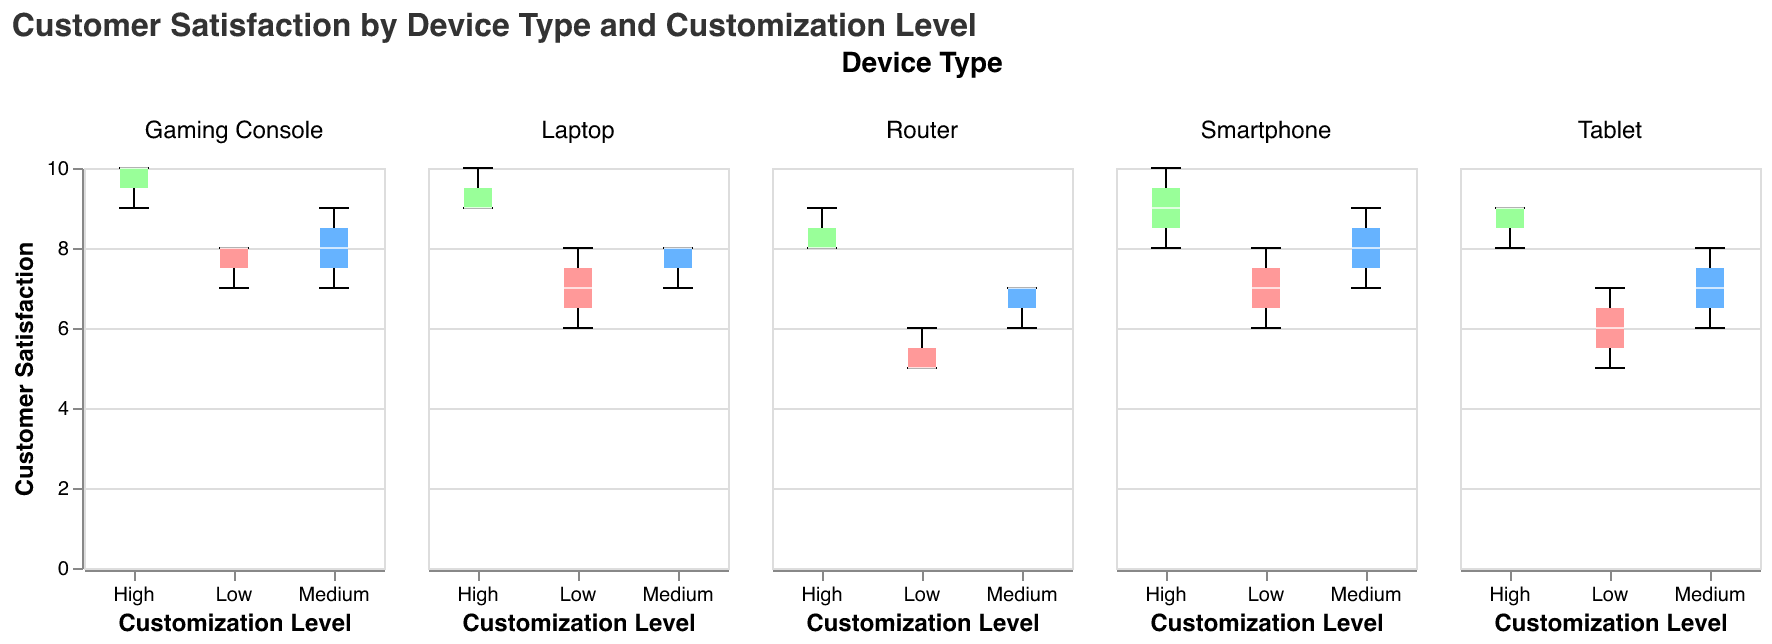What is the title of the figure? The title of the figure is located at the top of the plot and it reads: "Customer Satisfaction by Device Type and Customization Level".
Answer: Customer Satisfaction by Device Type and Customization Level What is the range of the customer satisfaction axis? The y-axis represents customer satisfaction, and the scale ranges from 0 to 10 according to the axis labels.
Answer: 0 to 10 How many device types are displayed in the plot? The plot facets the data by device types, with each subplot labeled with a different device type. Counting these labels, we find five different device types.
Answer: 5 Which customization level has the highest customer satisfaction median for Smartphones? By looking for the highest median line within the box plots for the different customization levels of Smartphones, we see that "High" customization level has the highest median.
Answer: High Is the customer satisfaction for Routers generally higher for higher customization levels? Compare the medians and the overall spread of the box plots for Routers at each customization level. The median and range both increase with higher customization levels, indicating higher customer satisfaction for higher customization levels.
Answer: Yes Which device type has the most consistent customer satisfaction ratings at the highest customization level? Consistency can be judged by the smallest interquartile range (width of the box) and smallest range between minimum and maximum values at the high customization level. The "Gaming Console" has the smallest range of customer satisfaction ratings at the high customization level.
Answer: Gaming Console For Tablets, which customization level shows the widest range of customer satisfaction? The width of the box plots and the range (distance between min and max values) indicate the range of satisfaction. For Tablets, the "Low" customization level shows the widest range from 5 to 7.
Answer: Low Between Laptops and Gaming Consoles, which one has a higher customer satisfaction median at medium customization levels? Examine the median lines for both Laptops and Gaming Consoles at the medium customization level. "Gaming Console" has a median of around 8, while "Laptop" has a median of 7.5.
Answer: Gaming Console Does the customer satisfaction ever decrease with higher customization levels for any device type? Review the medians and ranges of each customization level across all device types. Customer satisfaction does not decrease with higher customization levels for any device type; it either stays constant or increases.
Answer: No Compare the median customer satisfaction for Routers and Tablets at the medium customization level. Which is higher? Look at the median lines of the box plots for both Routers and Tablets at the medium customization level. Routers have a median of about 6.7, while Tablets have a median of 7.
Answer: Tablets 